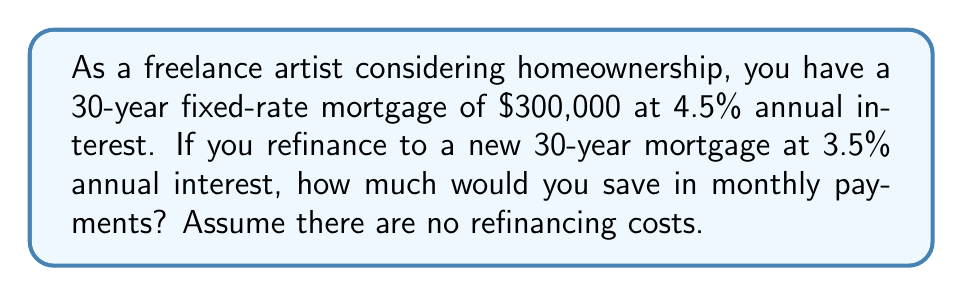Teach me how to tackle this problem. Let's break this down step-by-step:

1) First, we need to calculate the monthly payment for the current mortgage:
   
   The formula for monthly mortgage payments is:
   $$ P = L \frac{r(1+r)^n}{(1+r)^n - 1} $$
   Where:
   $P$ = monthly payment
   $L$ = loan amount
   $r$ = monthly interest rate (annual rate divided by 12)
   $n$ = total number of months (30 years * 12 months)

2) For the current mortgage:
   $L = 300,000$
   $r = 0.045 / 12 = 0.00375$
   $n = 30 * 12 = 360$

3) Plugging these values into the formula:
   $$ P_1 = 300,000 \frac{0.00375(1+0.00375)^{360}}{(1+0.00375)^{360} - 1} $$
   $$ P_1 \approx 1,520.06 $$

4) Now, let's calculate the monthly payment for the refinanced mortgage:
   $L = 300,000$
   $r = 0.035 / 12 = 0.002917$
   $n = 360$

5) Using the same formula:
   $$ P_2 = 300,000 \frac{0.002917(1+0.002917)^{360}}{(1+0.002917)^{360} - 1} $$
   $$ P_2 \approx 1,347.13 $$

6) The monthly savings would be the difference between these two payments:
   $$ \text{Savings} = P_1 - P_2 = 1,520.06 - 1,347.13 = 172.93 $$
Answer: $172.93 per month 